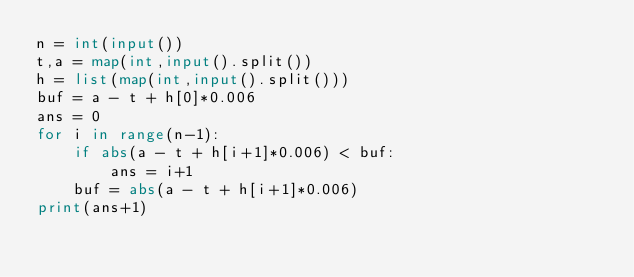<code> <loc_0><loc_0><loc_500><loc_500><_Python_>n = int(input())
t,a = map(int,input().split())
h = list(map(int,input().split()))
buf = a - t + h[0]*0.006
ans = 0
for i in range(n-1):
    if abs(a - t + h[i+1]*0.006) < buf:
        ans = i+1
    buf = abs(a - t + h[i+1]*0.006)
print(ans+1)</code> 